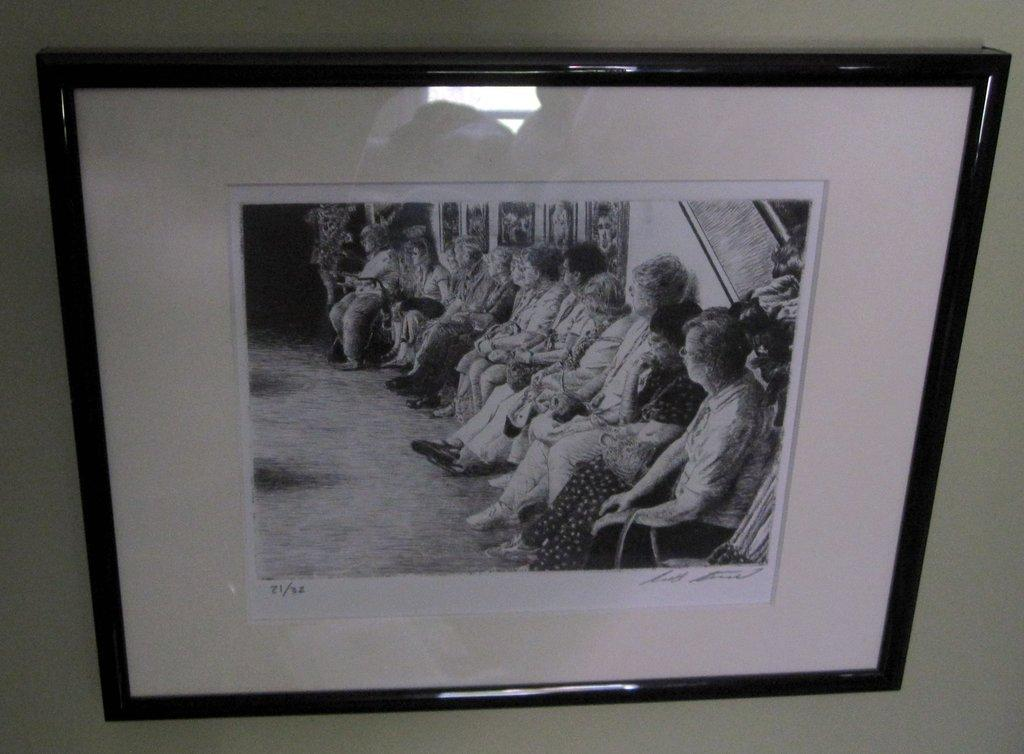<image>
Create a compact narrative representing the image presented. An old black and white photograph with 71/32 in the lower left hand corner. 